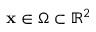Convert formula to latex. <formula><loc_0><loc_0><loc_500><loc_500>x \in \Omega \subset \mathbb { R } ^ { 2 }</formula> 